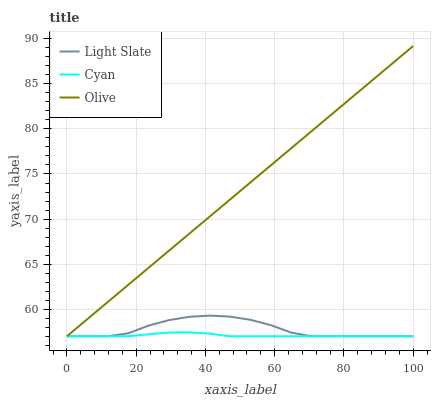Does Cyan have the minimum area under the curve?
Answer yes or no. Yes. Does Olive have the maximum area under the curve?
Answer yes or no. Yes. Does Olive have the minimum area under the curve?
Answer yes or no. No. Does Cyan have the maximum area under the curve?
Answer yes or no. No. Is Olive the smoothest?
Answer yes or no. Yes. Is Light Slate the roughest?
Answer yes or no. Yes. Is Cyan the smoothest?
Answer yes or no. No. Is Cyan the roughest?
Answer yes or no. No. Does Light Slate have the lowest value?
Answer yes or no. Yes. Does Olive have the highest value?
Answer yes or no. Yes. Does Cyan have the highest value?
Answer yes or no. No. Does Light Slate intersect Olive?
Answer yes or no. Yes. Is Light Slate less than Olive?
Answer yes or no. No. Is Light Slate greater than Olive?
Answer yes or no. No. 